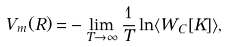Convert formula to latex. <formula><loc_0><loc_0><loc_500><loc_500>V _ { m } ( R ) = & - \lim _ { T \rightarrow \infty } \frac { 1 } { T } \ln \langle W _ { C } [ K ] \rangle ,</formula> 